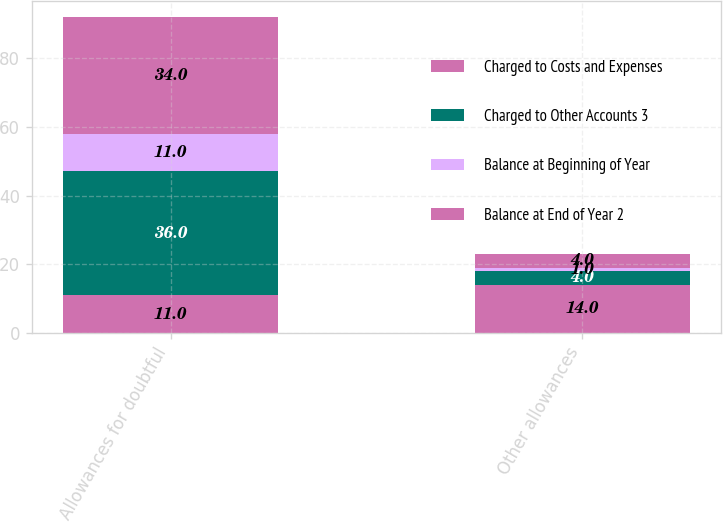Convert chart. <chart><loc_0><loc_0><loc_500><loc_500><stacked_bar_chart><ecel><fcel>Allowances for doubtful<fcel>Other allowances<nl><fcel>Charged to Costs and Expenses<fcel>11<fcel>14<nl><fcel>Charged to Other Accounts 3<fcel>36<fcel>4<nl><fcel>Balance at Beginning of Year<fcel>11<fcel>1<nl><fcel>Balance at End of Year 2<fcel>34<fcel>4<nl></chart> 